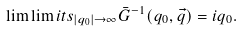<formula> <loc_0><loc_0><loc_500><loc_500>\lim \lim i t s _ { | q _ { 0 } | \to \infty } \bar { G } ^ { - 1 } ( q _ { 0 } , \vec { q } ) = i q _ { 0 } .</formula> 